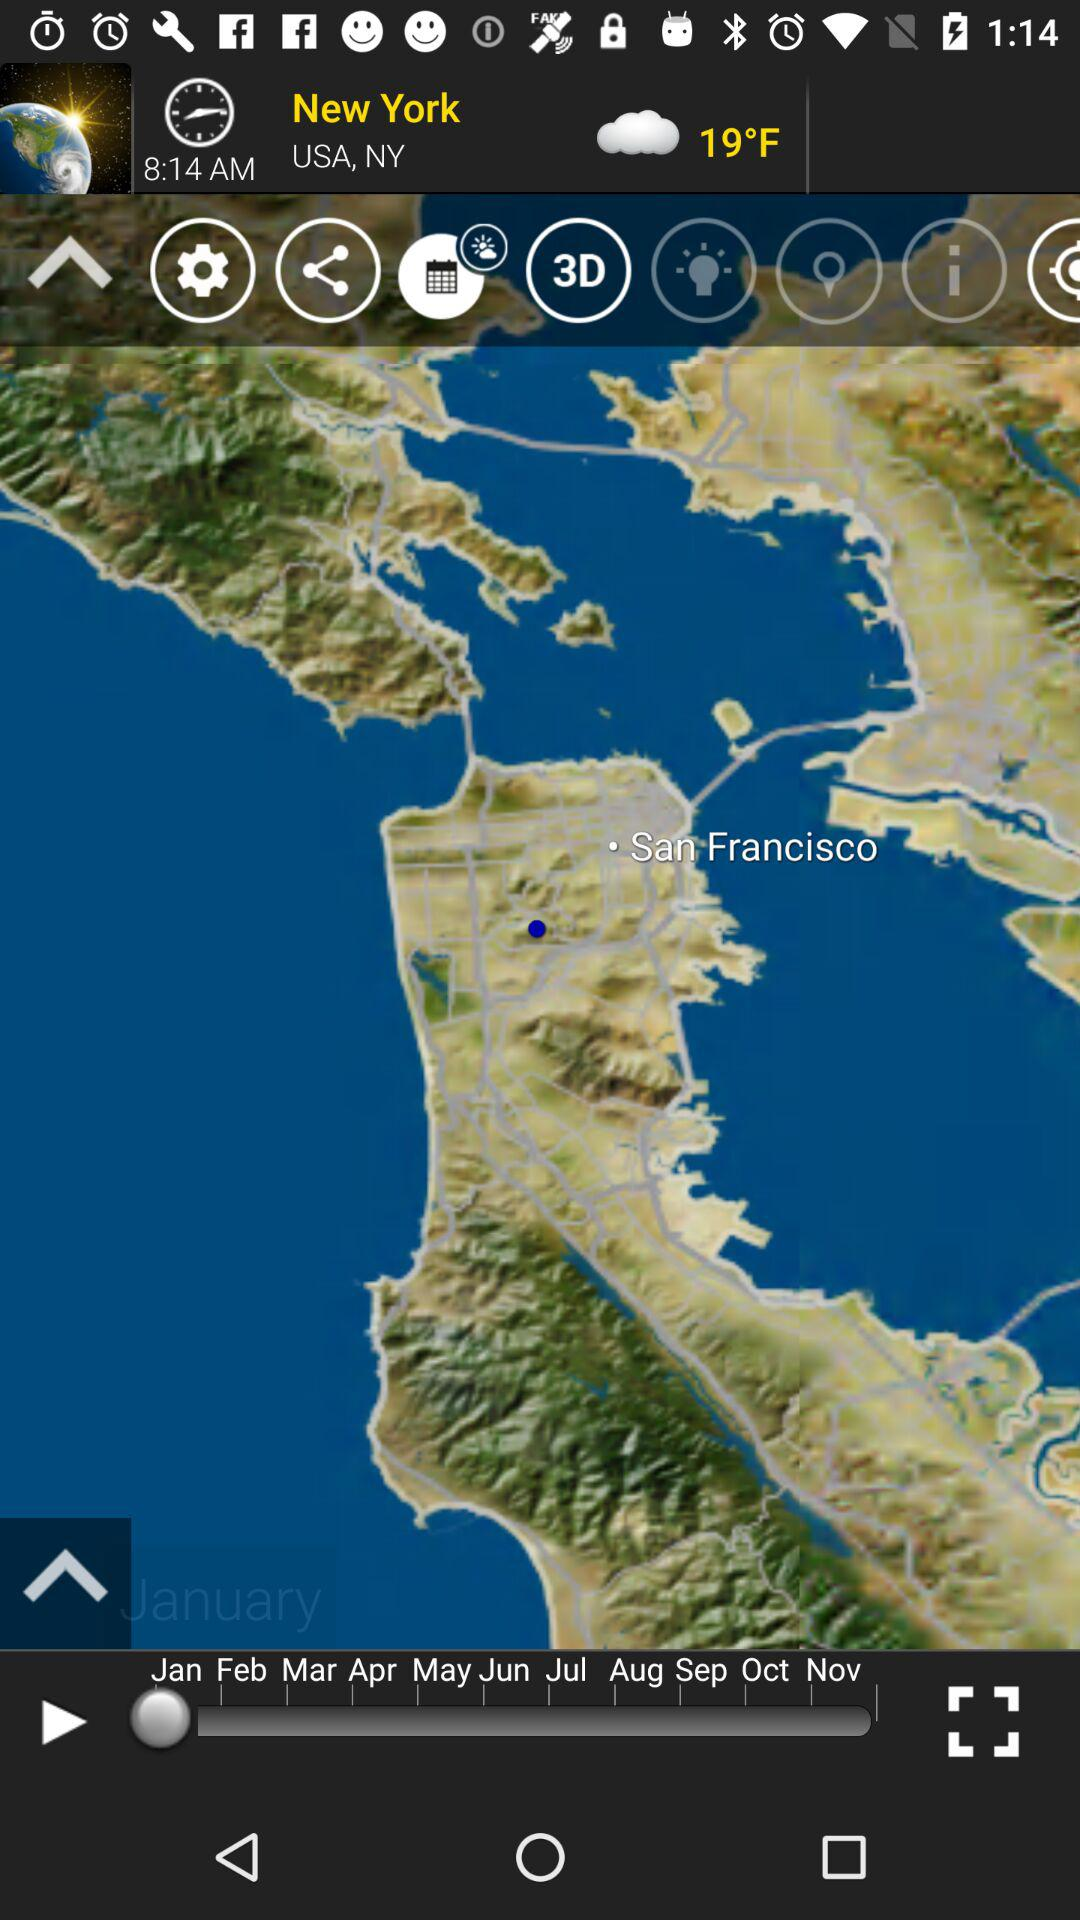What is the time? The time is 8:14 AM. 